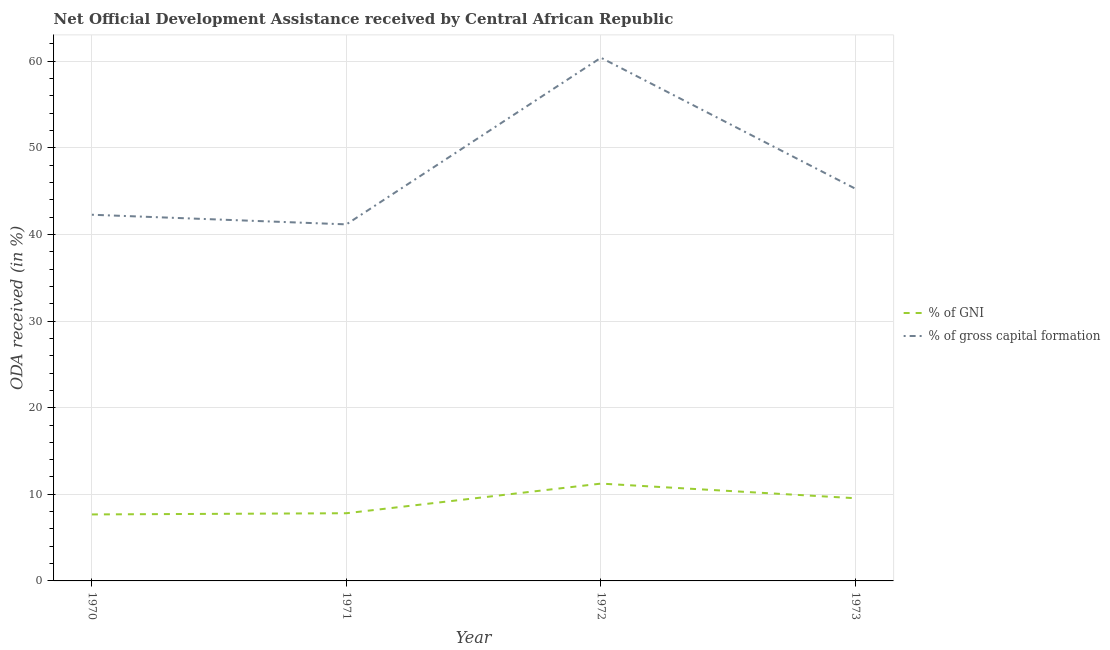Does the line corresponding to oda received as percentage of gni intersect with the line corresponding to oda received as percentage of gross capital formation?
Offer a very short reply. No. What is the oda received as percentage of gross capital formation in 1971?
Your answer should be very brief. 41.17. Across all years, what is the maximum oda received as percentage of gni?
Offer a terse response. 11.24. Across all years, what is the minimum oda received as percentage of gni?
Provide a short and direct response. 7.68. What is the total oda received as percentage of gross capital formation in the graph?
Offer a terse response. 189.16. What is the difference between the oda received as percentage of gni in 1970 and that in 1971?
Make the answer very short. -0.14. What is the difference between the oda received as percentage of gni in 1970 and the oda received as percentage of gross capital formation in 1973?
Ensure brevity in your answer.  -37.61. What is the average oda received as percentage of gross capital formation per year?
Your response must be concise. 47.29. In the year 1970, what is the difference between the oda received as percentage of gni and oda received as percentage of gross capital formation?
Your answer should be very brief. -34.61. In how many years, is the oda received as percentage of gni greater than 14 %?
Your answer should be compact. 0. What is the ratio of the oda received as percentage of gross capital formation in 1970 to that in 1972?
Provide a succinct answer. 0.7. What is the difference between the highest and the second highest oda received as percentage of gross capital formation?
Offer a very short reply. 15.13. What is the difference between the highest and the lowest oda received as percentage of gni?
Keep it short and to the point. 3.56. Does the oda received as percentage of gni monotonically increase over the years?
Make the answer very short. No. Is the oda received as percentage of gross capital formation strictly greater than the oda received as percentage of gni over the years?
Provide a short and direct response. Yes. How many years are there in the graph?
Your answer should be very brief. 4. What is the difference between two consecutive major ticks on the Y-axis?
Offer a terse response. 10. Are the values on the major ticks of Y-axis written in scientific E-notation?
Keep it short and to the point. No. Where does the legend appear in the graph?
Provide a short and direct response. Center right. How many legend labels are there?
Make the answer very short. 2. How are the legend labels stacked?
Your answer should be compact. Vertical. What is the title of the graph?
Provide a short and direct response. Net Official Development Assistance received by Central African Republic. Does "Enforce a contract" appear as one of the legend labels in the graph?
Give a very brief answer. No. What is the label or title of the Y-axis?
Offer a very short reply. ODA received (in %). What is the ODA received (in %) in % of GNI in 1970?
Provide a short and direct response. 7.68. What is the ODA received (in %) in % of gross capital formation in 1970?
Give a very brief answer. 42.28. What is the ODA received (in %) of % of GNI in 1971?
Your answer should be very brief. 7.82. What is the ODA received (in %) in % of gross capital formation in 1971?
Your answer should be compact. 41.17. What is the ODA received (in %) in % of GNI in 1972?
Offer a very short reply. 11.24. What is the ODA received (in %) in % of gross capital formation in 1972?
Provide a short and direct response. 60.42. What is the ODA received (in %) in % of GNI in 1973?
Offer a terse response. 9.55. What is the ODA received (in %) of % of gross capital formation in 1973?
Your response must be concise. 45.29. Across all years, what is the maximum ODA received (in %) of % of GNI?
Your response must be concise. 11.24. Across all years, what is the maximum ODA received (in %) in % of gross capital formation?
Give a very brief answer. 60.42. Across all years, what is the minimum ODA received (in %) of % of GNI?
Ensure brevity in your answer.  7.68. Across all years, what is the minimum ODA received (in %) of % of gross capital formation?
Offer a terse response. 41.17. What is the total ODA received (in %) in % of GNI in the graph?
Your response must be concise. 36.28. What is the total ODA received (in %) of % of gross capital formation in the graph?
Your answer should be very brief. 189.16. What is the difference between the ODA received (in %) in % of GNI in 1970 and that in 1971?
Offer a very short reply. -0.14. What is the difference between the ODA received (in %) of % of gross capital formation in 1970 and that in 1971?
Your answer should be very brief. 1.11. What is the difference between the ODA received (in %) of % of GNI in 1970 and that in 1972?
Offer a very short reply. -3.56. What is the difference between the ODA received (in %) of % of gross capital formation in 1970 and that in 1972?
Give a very brief answer. -18.13. What is the difference between the ODA received (in %) of % of GNI in 1970 and that in 1973?
Provide a short and direct response. -1.87. What is the difference between the ODA received (in %) of % of gross capital formation in 1970 and that in 1973?
Offer a very short reply. -3. What is the difference between the ODA received (in %) of % of GNI in 1971 and that in 1972?
Keep it short and to the point. -3.42. What is the difference between the ODA received (in %) in % of gross capital formation in 1971 and that in 1972?
Offer a very short reply. -19.24. What is the difference between the ODA received (in %) of % of GNI in 1971 and that in 1973?
Ensure brevity in your answer.  -1.73. What is the difference between the ODA received (in %) in % of gross capital formation in 1971 and that in 1973?
Your response must be concise. -4.11. What is the difference between the ODA received (in %) in % of GNI in 1972 and that in 1973?
Keep it short and to the point. 1.69. What is the difference between the ODA received (in %) of % of gross capital formation in 1972 and that in 1973?
Your response must be concise. 15.13. What is the difference between the ODA received (in %) of % of GNI in 1970 and the ODA received (in %) of % of gross capital formation in 1971?
Offer a terse response. -33.49. What is the difference between the ODA received (in %) of % of GNI in 1970 and the ODA received (in %) of % of gross capital formation in 1972?
Provide a short and direct response. -52.74. What is the difference between the ODA received (in %) in % of GNI in 1970 and the ODA received (in %) in % of gross capital formation in 1973?
Your answer should be very brief. -37.61. What is the difference between the ODA received (in %) of % of GNI in 1971 and the ODA received (in %) of % of gross capital formation in 1972?
Provide a short and direct response. -52.6. What is the difference between the ODA received (in %) in % of GNI in 1971 and the ODA received (in %) in % of gross capital formation in 1973?
Keep it short and to the point. -37.47. What is the difference between the ODA received (in %) of % of GNI in 1972 and the ODA received (in %) of % of gross capital formation in 1973?
Your answer should be very brief. -34.05. What is the average ODA received (in %) in % of GNI per year?
Ensure brevity in your answer.  9.07. What is the average ODA received (in %) in % of gross capital formation per year?
Give a very brief answer. 47.29. In the year 1970, what is the difference between the ODA received (in %) of % of GNI and ODA received (in %) of % of gross capital formation?
Provide a short and direct response. -34.61. In the year 1971, what is the difference between the ODA received (in %) in % of GNI and ODA received (in %) in % of gross capital formation?
Offer a very short reply. -33.35. In the year 1972, what is the difference between the ODA received (in %) of % of GNI and ODA received (in %) of % of gross capital formation?
Your answer should be compact. -49.18. In the year 1973, what is the difference between the ODA received (in %) in % of GNI and ODA received (in %) in % of gross capital formation?
Your answer should be very brief. -35.74. What is the ratio of the ODA received (in %) of % of GNI in 1970 to that in 1971?
Keep it short and to the point. 0.98. What is the ratio of the ODA received (in %) in % of GNI in 1970 to that in 1972?
Make the answer very short. 0.68. What is the ratio of the ODA received (in %) of % of gross capital formation in 1970 to that in 1972?
Offer a very short reply. 0.7. What is the ratio of the ODA received (in %) of % of GNI in 1970 to that in 1973?
Your answer should be very brief. 0.8. What is the ratio of the ODA received (in %) in % of gross capital formation in 1970 to that in 1973?
Your answer should be very brief. 0.93. What is the ratio of the ODA received (in %) of % of GNI in 1971 to that in 1972?
Ensure brevity in your answer.  0.7. What is the ratio of the ODA received (in %) in % of gross capital formation in 1971 to that in 1972?
Provide a short and direct response. 0.68. What is the ratio of the ODA received (in %) in % of GNI in 1971 to that in 1973?
Provide a short and direct response. 0.82. What is the ratio of the ODA received (in %) in % of GNI in 1972 to that in 1973?
Offer a very short reply. 1.18. What is the ratio of the ODA received (in %) in % of gross capital formation in 1972 to that in 1973?
Provide a short and direct response. 1.33. What is the difference between the highest and the second highest ODA received (in %) of % of GNI?
Your response must be concise. 1.69. What is the difference between the highest and the second highest ODA received (in %) of % of gross capital formation?
Give a very brief answer. 15.13. What is the difference between the highest and the lowest ODA received (in %) of % of GNI?
Provide a succinct answer. 3.56. What is the difference between the highest and the lowest ODA received (in %) in % of gross capital formation?
Ensure brevity in your answer.  19.24. 